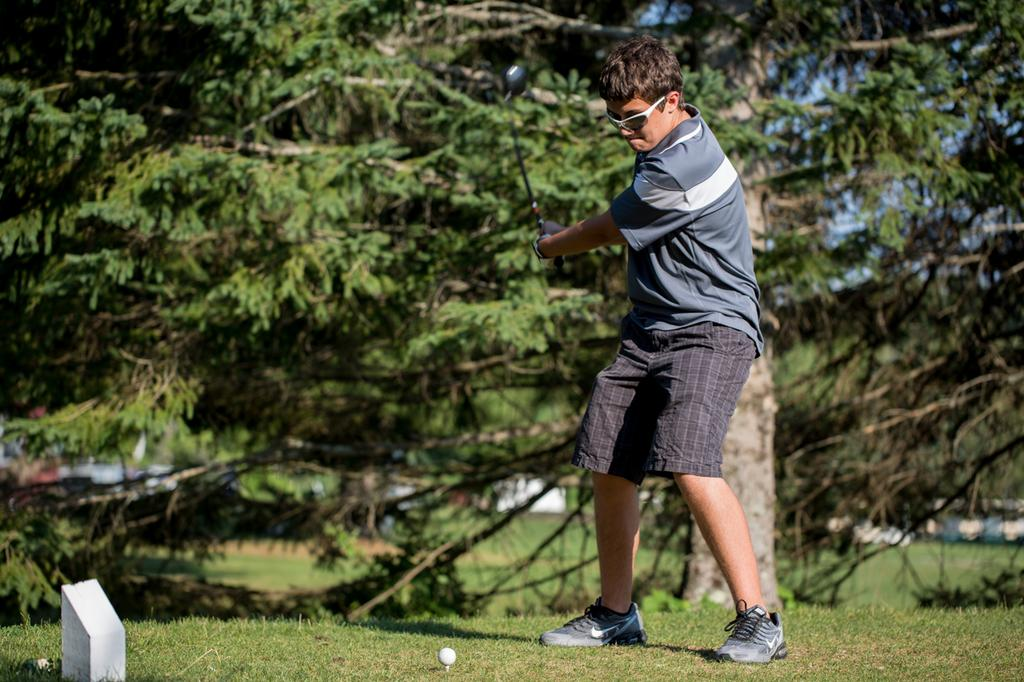What activity is the person in the image engaged in? The person is playing golf in the image. Where is the person playing golf located in the image? The person is in the center of the image. What type of terrain is visible at the bottom of the image? There is grass at the bottom of the image. What object is essential for playing golf that can be seen in the image? There is a golf ball in the image. What can be seen in the distance behind the person playing golf? There are trees in the background of the image. What type of current can be seen flowing through the golf course in the image? There is no current visible in the image; it is a golf course with grass, trees, and a person playing golf. 